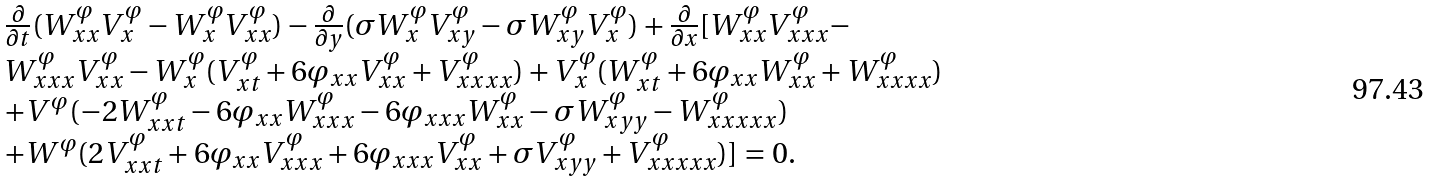Convert formula to latex. <formula><loc_0><loc_0><loc_500><loc_500>\begin{array} { l } \frac { \partial } { \partial t } ( W ^ { \varphi } _ { x x } V ^ { \varphi } _ { x } - W _ { x } ^ { \varphi } V _ { x x } ^ { \varphi } ) - \frac { \partial } { \partial y } ( \sigma W _ { x } ^ { \varphi } V ^ { \varphi } _ { x y } - \sigma W _ { x y } ^ { \varphi } V ^ { \varphi } _ { x } ) + \frac { \partial } { \partial x } [ W ^ { \varphi } _ { x x } V ^ { \varphi } _ { x x x } - \\ W _ { x x x } ^ { \varphi } V _ { x x } ^ { \varphi } - W ^ { \varphi } _ { x } ( V _ { x t } ^ { \varphi } + 6 \varphi _ { x x } V ^ { \varphi } _ { x x } + V ^ { \varphi } _ { x x x x } ) + V ^ { \varphi } _ { x } ( W _ { x t } ^ { \varphi } + 6 \varphi _ { x x } W ^ { \varphi } _ { x x } + W ^ { \varphi } _ { x x x x } ) \\ + V ^ { \varphi } ( - 2 W _ { x x t } ^ { \varphi } - 6 \varphi _ { x x } W ^ { \varphi } _ { x x x } - 6 \varphi _ { x x x } W ^ { \varphi } _ { x x } - \sigma W ^ { \varphi } _ { x y y } - W ^ { \varphi } _ { x x x x x } ) \\ + W ^ { \varphi } ( 2 V _ { x x t } ^ { \varphi } + 6 \varphi _ { x x } V ^ { \varphi } _ { x x x } + 6 \varphi _ { x x x } V ^ { \varphi } _ { x x } + \sigma V ^ { \varphi } _ { x y y } + V ^ { \varphi } _ { x x x x x } ) ] = 0 . \end{array}</formula> 